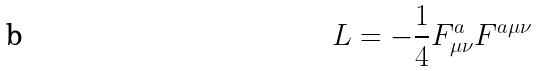Convert formula to latex. <formula><loc_0><loc_0><loc_500><loc_500>L = - \frac { 1 } { 4 } F ^ { a } _ { \mu \nu } F ^ { a \mu \nu }</formula> 